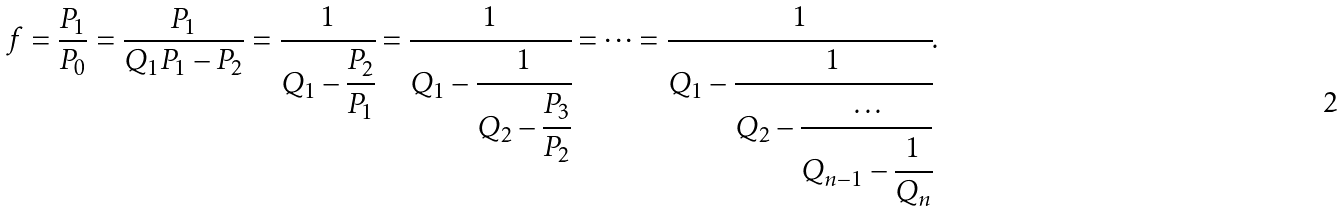<formula> <loc_0><loc_0><loc_500><loc_500>f = \frac { P _ { 1 } } { P _ { 0 } } = \frac { P _ { 1 } } { Q _ { 1 } P _ { 1 } - P _ { 2 } } = \cfrac { 1 } { Q _ { 1 } - \cfrac { P _ { 2 } } { P _ { 1 } } } = \cfrac { 1 } { Q _ { 1 } - \cfrac { 1 } { Q _ { 2 } - \cfrac { P _ { 3 } } { P _ { 2 } } } } = \dots = \cfrac { 1 } { Q _ { 1 } - \cfrac { 1 } { Q _ { 2 } - \cfrac { \dots } { Q _ { n - 1 } - \cfrac { 1 } { Q _ { n } } } } } .</formula> 